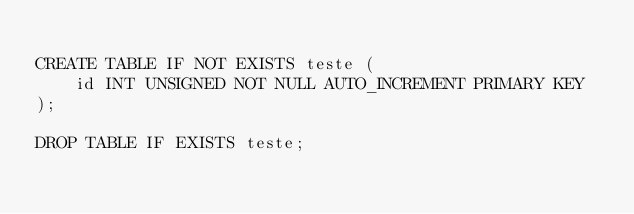<code> <loc_0><loc_0><loc_500><loc_500><_SQL_>
CREATE TABLE IF NOT EXISTS teste (
    id INT UNSIGNED NOT NULL AUTO_INCREMENT PRIMARY KEY
);

DROP TABLE IF EXISTS teste;</code> 